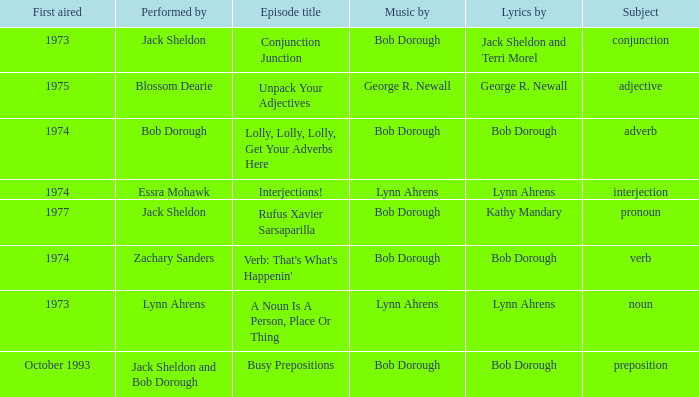Who is the performer in the episode titled "conjunction junction" with music by bob dorough? Jack Sheldon. 